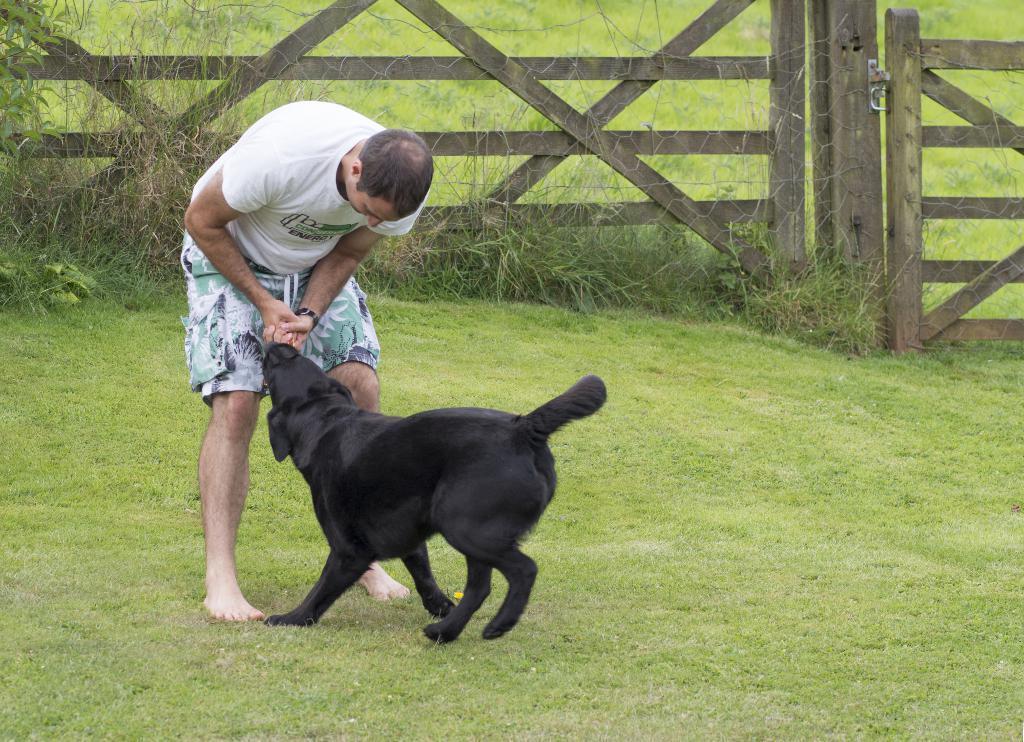Can you describe this image briefly? This picture shows a man playing with a dog which is in black color in a garden. There is a wooden railing in the background and some plants here. 